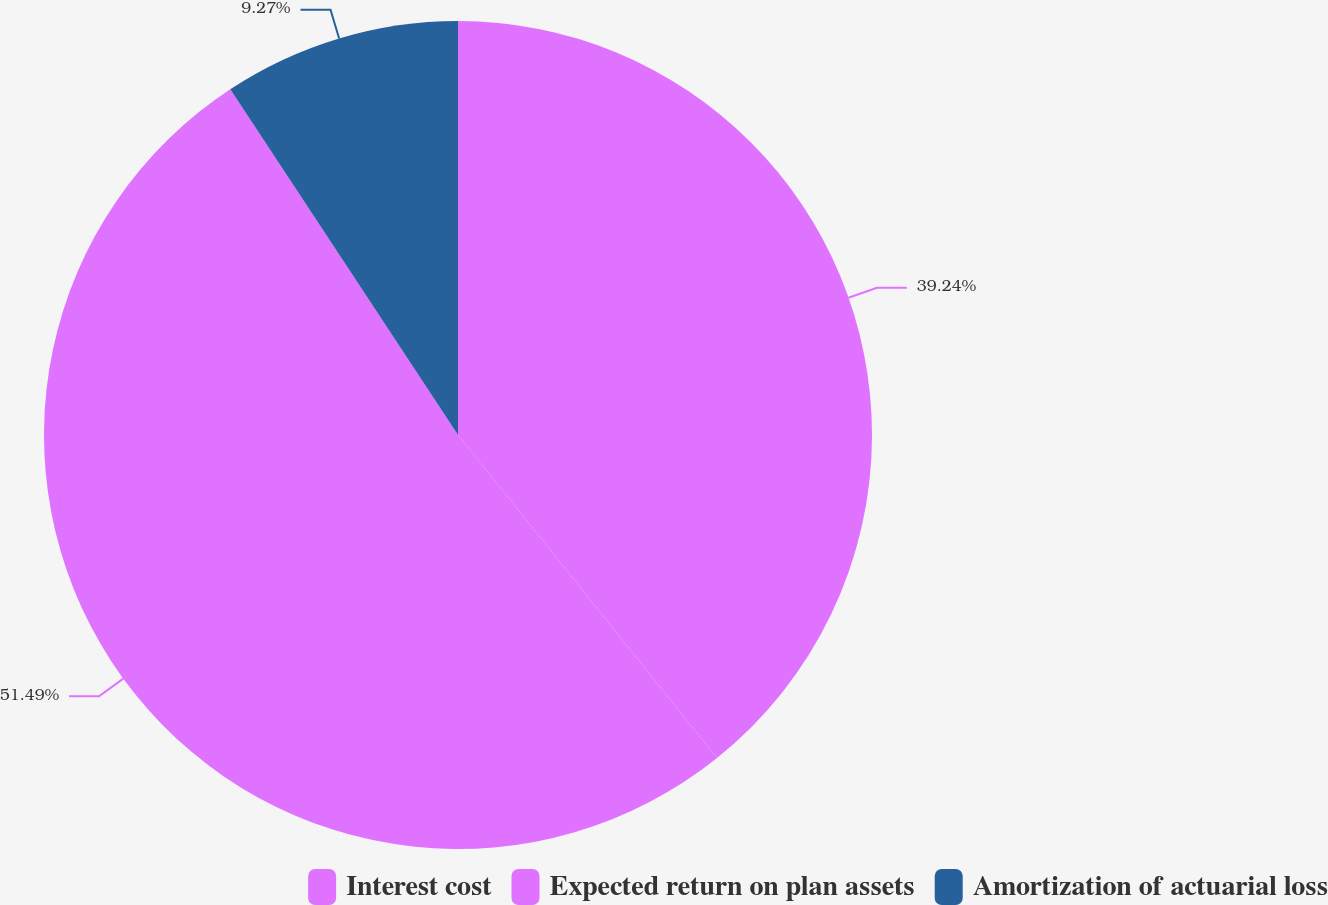Convert chart. <chart><loc_0><loc_0><loc_500><loc_500><pie_chart><fcel>Interest cost<fcel>Expected return on plan assets<fcel>Amortization of actuarial loss<nl><fcel>39.24%<fcel>51.49%<fcel>9.27%<nl></chart> 